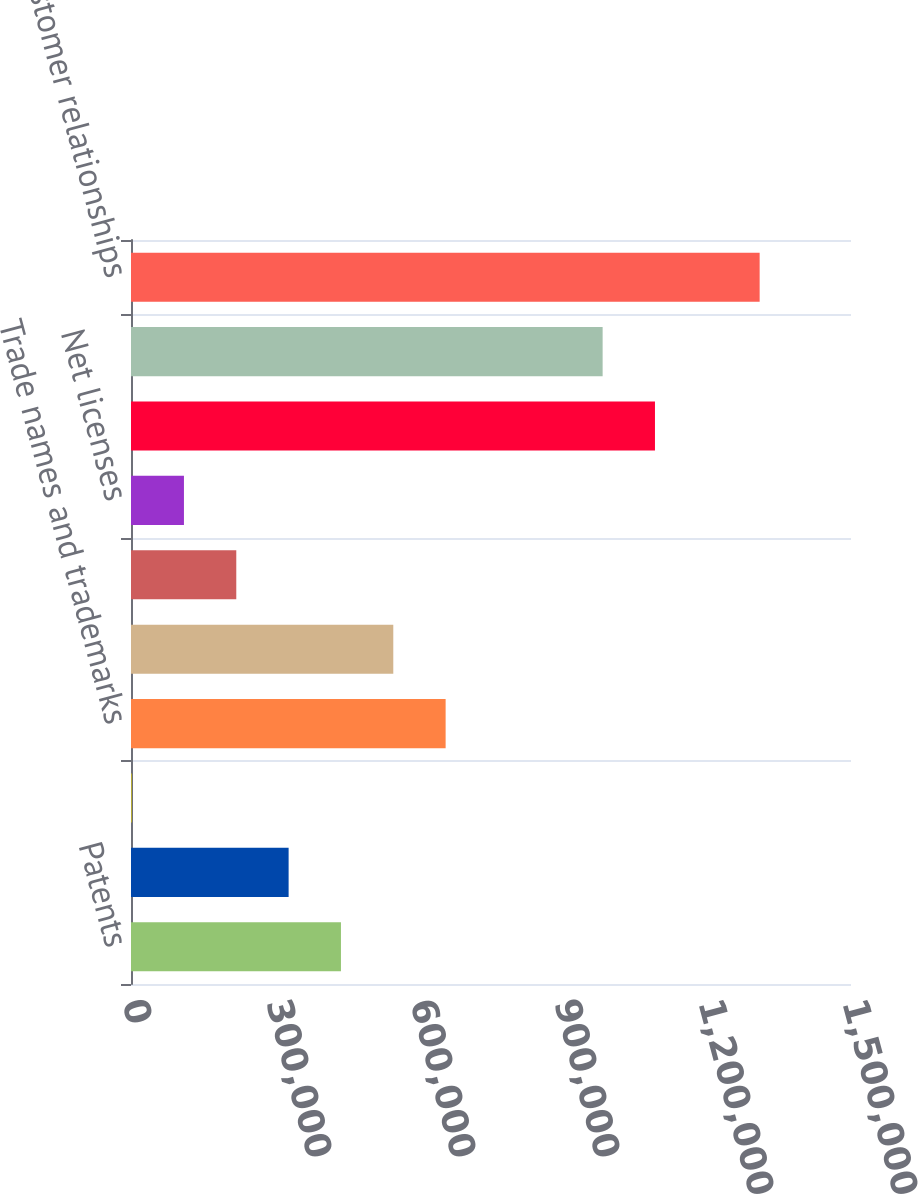Convert chart. <chart><loc_0><loc_0><loc_500><loc_500><bar_chart><fcel>Patents<fcel>Less Accumulated amortization<fcel>Net patents<fcel>Trade names and trademarks<fcel>Net trade names and trademarks<fcel>Licenses<fcel>Net licenses<fcel>Core technology<fcel>Net core technology<fcel>Customer relationships<nl><fcel>437408<fcel>328374<fcel>1274<fcel>655475<fcel>546442<fcel>219341<fcel>110308<fcel>1.09161e+06<fcel>982576<fcel>1.30968e+06<nl></chart> 